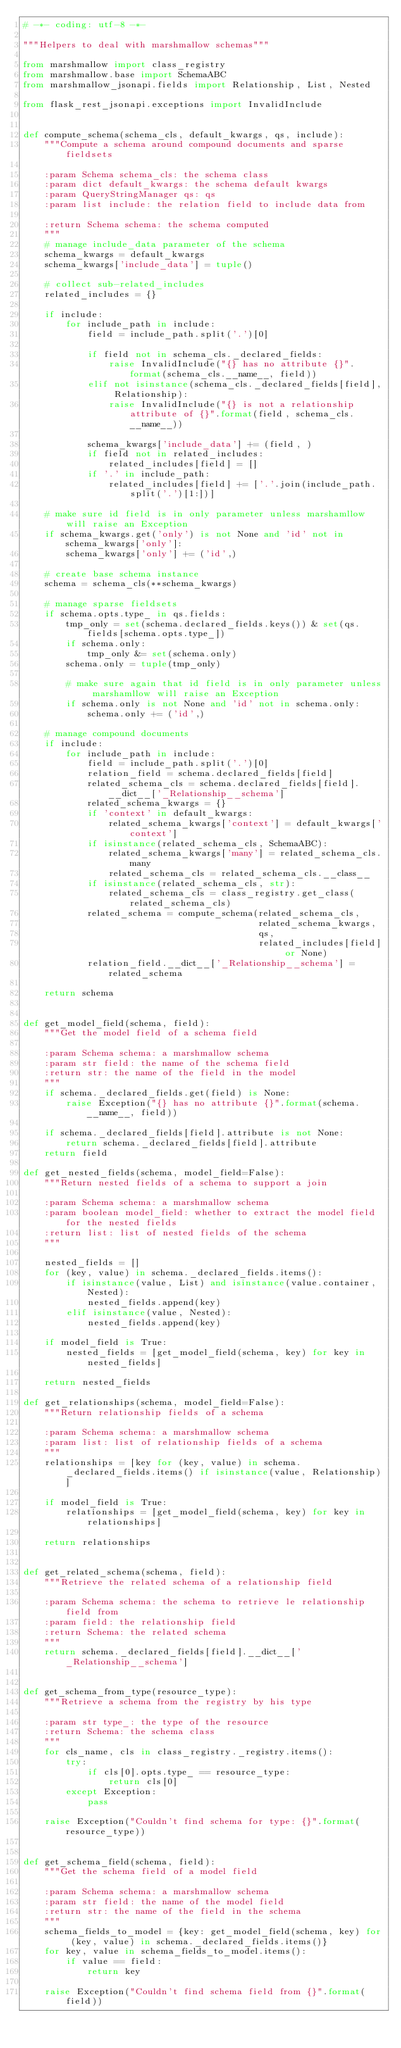<code> <loc_0><loc_0><loc_500><loc_500><_Python_># -*- coding: utf-8 -*-

"""Helpers to deal with marshmallow schemas"""

from marshmallow import class_registry
from marshmallow.base import SchemaABC
from marshmallow_jsonapi.fields import Relationship, List, Nested

from flask_rest_jsonapi.exceptions import InvalidInclude


def compute_schema(schema_cls, default_kwargs, qs, include):
    """Compute a schema around compound documents and sparse fieldsets

    :param Schema schema_cls: the schema class
    :param dict default_kwargs: the schema default kwargs
    :param QueryStringManager qs: qs
    :param list include: the relation field to include data from

    :return Schema schema: the schema computed
    """
    # manage include_data parameter of the schema
    schema_kwargs = default_kwargs
    schema_kwargs['include_data'] = tuple()

    # collect sub-related_includes
    related_includes = {}

    if include:
        for include_path in include:
            field = include_path.split('.')[0]

            if field not in schema_cls._declared_fields:
                raise InvalidInclude("{} has no attribute {}".format(schema_cls.__name__, field))
            elif not isinstance(schema_cls._declared_fields[field], Relationship):
                raise InvalidInclude("{} is not a relationship attribute of {}".format(field, schema_cls.__name__))

            schema_kwargs['include_data'] += (field, )
            if field not in related_includes:
                related_includes[field] = []
            if '.' in include_path:
                related_includes[field] += ['.'.join(include_path.split('.')[1:])]

    # make sure id field is in only parameter unless marshamllow will raise an Exception
    if schema_kwargs.get('only') is not None and 'id' not in schema_kwargs['only']:
        schema_kwargs['only'] += ('id',)

    # create base schema instance
    schema = schema_cls(**schema_kwargs)

    # manage sparse fieldsets
    if schema.opts.type_ in qs.fields:
        tmp_only = set(schema.declared_fields.keys()) & set(qs.fields[schema.opts.type_])
        if schema.only:
            tmp_only &= set(schema.only)
        schema.only = tuple(tmp_only)

        # make sure again that id field is in only parameter unless marshamllow will raise an Exception
        if schema.only is not None and 'id' not in schema.only:
            schema.only += ('id',)

    # manage compound documents
    if include:
        for include_path in include:
            field = include_path.split('.')[0]
            relation_field = schema.declared_fields[field]
            related_schema_cls = schema.declared_fields[field].__dict__['_Relationship__schema']
            related_schema_kwargs = {}
            if 'context' in default_kwargs:
                related_schema_kwargs['context'] = default_kwargs['context']
            if isinstance(related_schema_cls, SchemaABC):
                related_schema_kwargs['many'] = related_schema_cls.many
                related_schema_cls = related_schema_cls.__class__
            if isinstance(related_schema_cls, str):
                related_schema_cls = class_registry.get_class(related_schema_cls)
            related_schema = compute_schema(related_schema_cls,
                                            related_schema_kwargs,
                                            qs,
                                            related_includes[field] or None)
            relation_field.__dict__['_Relationship__schema'] = related_schema

    return schema


def get_model_field(schema, field):
    """Get the model field of a schema field

    :param Schema schema: a marshmallow schema
    :param str field: the name of the schema field
    :return str: the name of the field in the model
    """
    if schema._declared_fields.get(field) is None:
        raise Exception("{} has no attribute {}".format(schema.__name__, field))

    if schema._declared_fields[field].attribute is not None:
        return schema._declared_fields[field].attribute
    return field

def get_nested_fields(schema, model_field=False):
    """Return nested fields of a schema to support a join

    :param Schema schema: a marshmallow schema
    :param boolean model_field: whether to extract the model field for the nested fields
    :return list: list of nested fields of the schema
    """

    nested_fields = []
    for (key, value) in schema._declared_fields.items():
        if isinstance(value, List) and isinstance(value.container, Nested):
            nested_fields.append(key)
        elif isinstance(value, Nested):
            nested_fields.append(key)

    if model_field is True:
        nested_fields = [get_model_field(schema, key) for key in nested_fields]

    return nested_fields

def get_relationships(schema, model_field=False):
    """Return relationship fields of a schema

    :param Schema schema: a marshmallow schema
    :param list: list of relationship fields of a schema
    """
    relationships = [key for (key, value) in schema._declared_fields.items() if isinstance(value, Relationship)]

    if model_field is True:
        relationships = [get_model_field(schema, key) for key in relationships]

    return relationships


def get_related_schema(schema, field):
    """Retrieve the related schema of a relationship field

    :param Schema schema: the schema to retrieve le relationship field from
    :param field: the relationship field
    :return Schema: the related schema
    """
    return schema._declared_fields[field].__dict__['_Relationship__schema']


def get_schema_from_type(resource_type):
    """Retrieve a schema from the registry by his type

    :param str type_: the type of the resource
    :return Schema: the schema class
    """
    for cls_name, cls in class_registry._registry.items():
        try:
            if cls[0].opts.type_ == resource_type:
                return cls[0]
        except Exception:
            pass

    raise Exception("Couldn't find schema for type: {}".format(resource_type))


def get_schema_field(schema, field):
    """Get the schema field of a model field

    :param Schema schema: a marshmallow schema
    :param str field: the name of the model field
    :return str: the name of the field in the schema
    """
    schema_fields_to_model = {key: get_model_field(schema, key) for (key, value) in schema._declared_fields.items()}
    for key, value in schema_fields_to_model.items():
        if value == field:
            return key

    raise Exception("Couldn't find schema field from {}".format(field))
</code> 